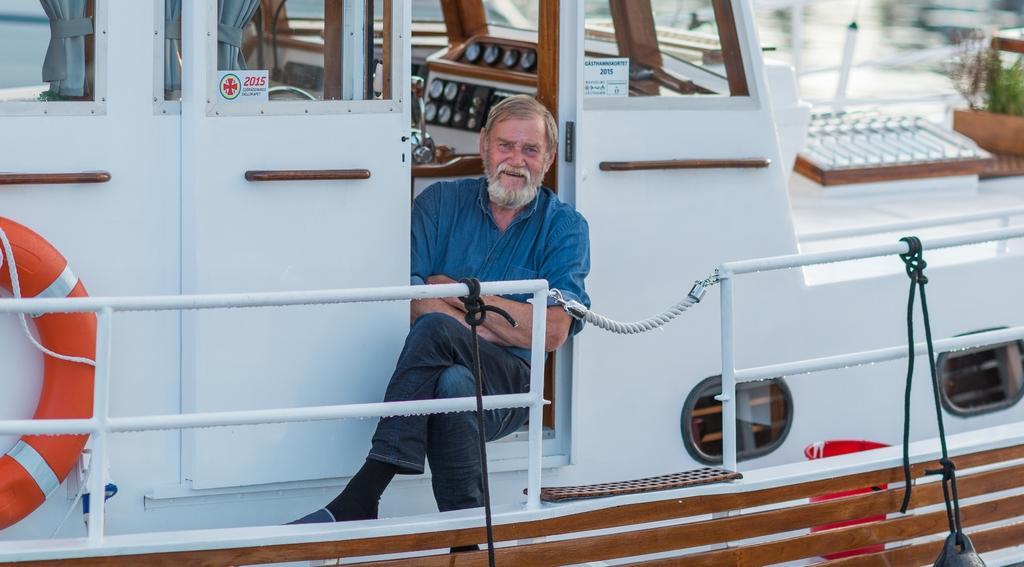Please provide a concise description of this image. In this image, in the middle, we can see a man sitting on the boat, we can also see some metal rods, water tubes which are attached to a boat and the boat is in white color. In the background, we can see a water, few plants. 